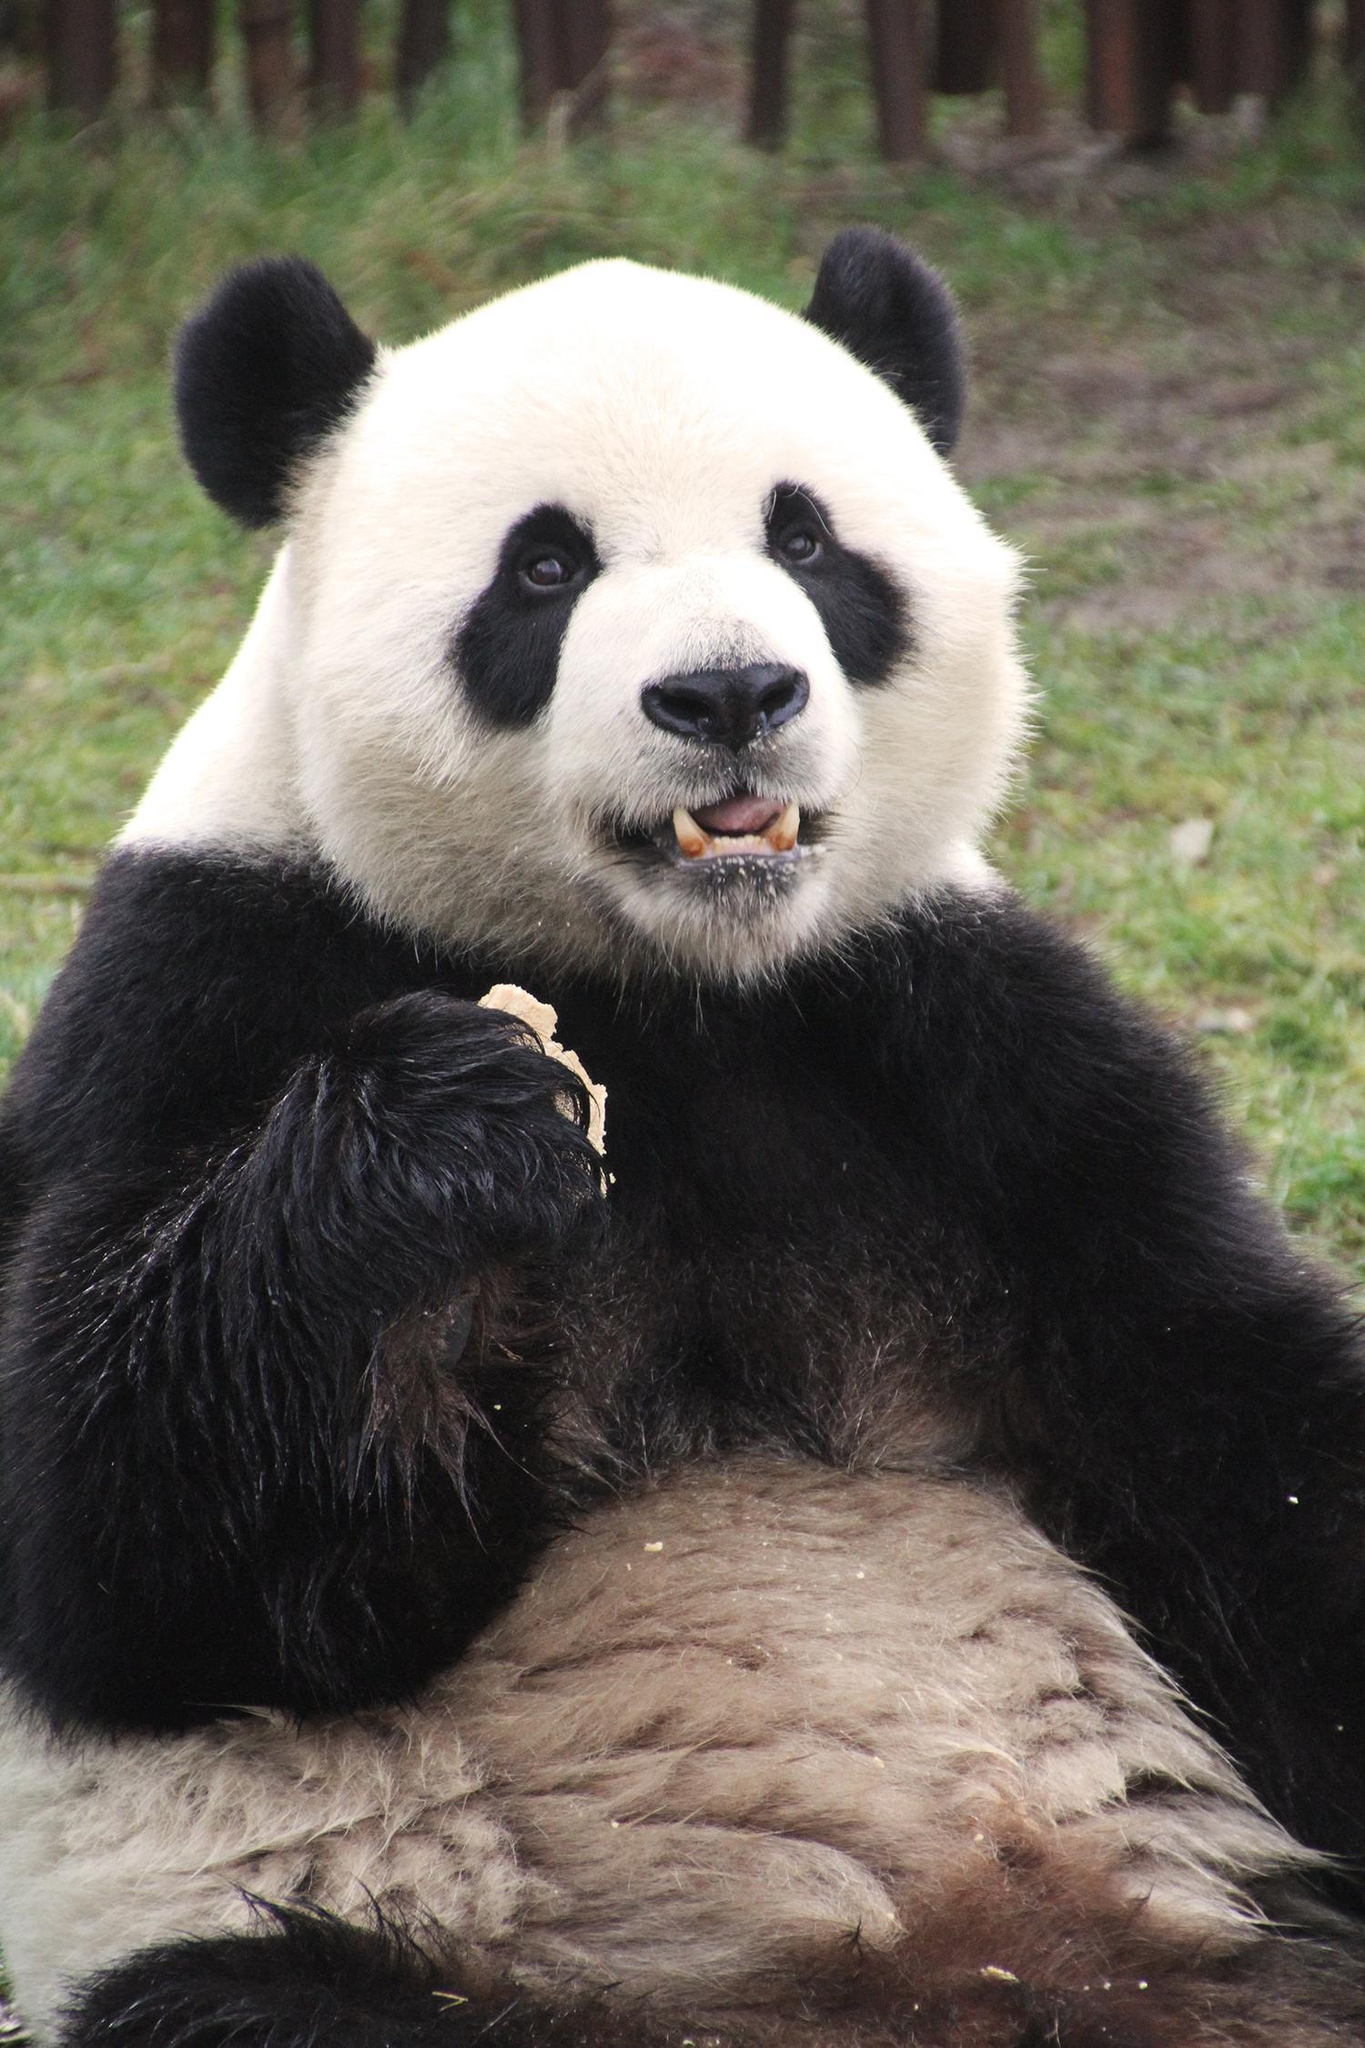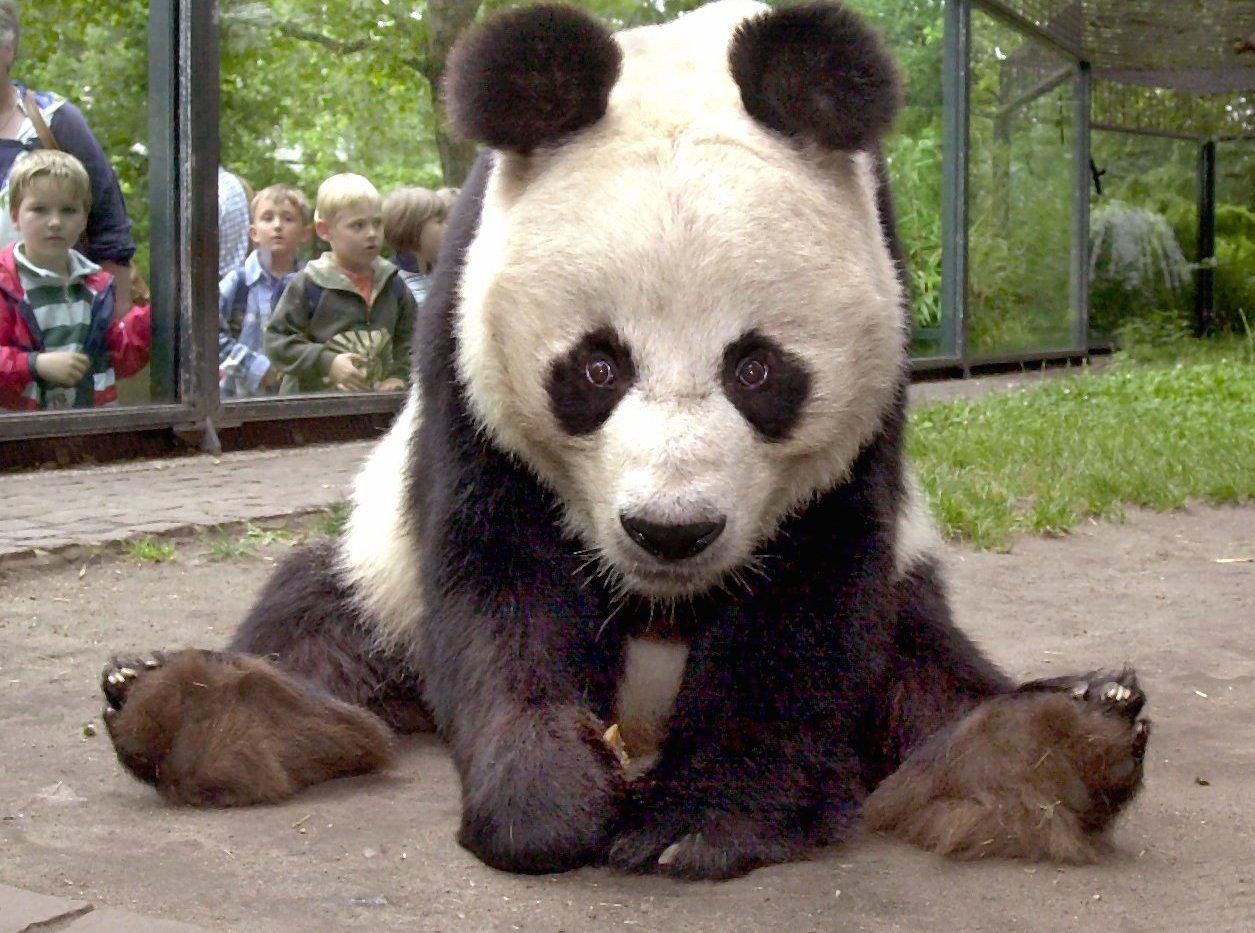The first image is the image on the left, the second image is the image on the right. Given the left and right images, does the statement "There is at least one human face behind a panda bear." hold true? Answer yes or no. Yes. The first image is the image on the left, the second image is the image on the right. Given the left and right images, does the statement "There are no people, only pandas, and one of the pandas is with plants." hold true? Answer yes or no. No. 